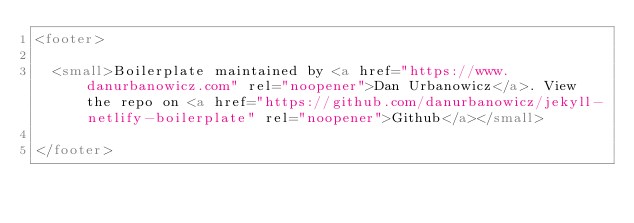Convert code to text. <code><loc_0><loc_0><loc_500><loc_500><_HTML_><footer>

  <small>Boilerplate maintained by <a href="https://www.danurbanowicz.com" rel="noopener">Dan Urbanowicz</a>. View the repo on <a href="https://github.com/danurbanowicz/jekyll-netlify-boilerplate" rel="noopener">Github</a></small>

</footer>
</code> 